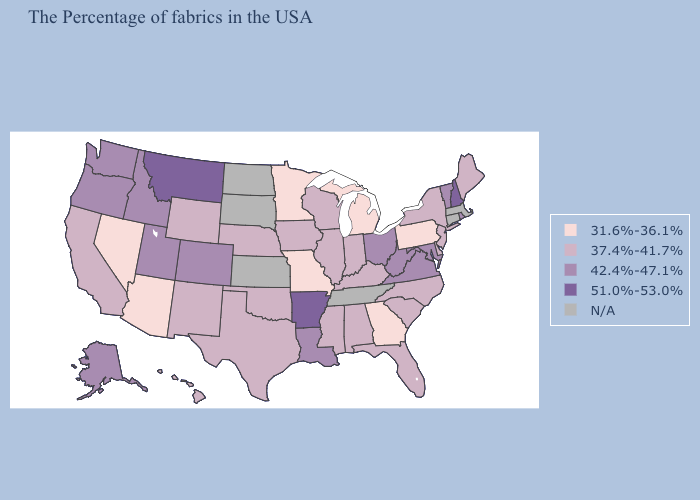What is the value of Ohio?
Short answer required. 42.4%-47.1%. Name the states that have a value in the range 31.6%-36.1%?
Answer briefly. Pennsylvania, Georgia, Michigan, Missouri, Minnesota, Arizona, Nevada. What is the value of Arizona?
Give a very brief answer. 31.6%-36.1%. Name the states that have a value in the range 51.0%-53.0%?
Short answer required. New Hampshire, Arkansas, Montana. What is the lowest value in the South?
Give a very brief answer. 31.6%-36.1%. Does California have the lowest value in the West?
Keep it brief. No. Among the states that border New Hampshire , does Vermont have the highest value?
Write a very short answer. Yes. What is the value of Nebraska?
Short answer required. 37.4%-41.7%. Name the states that have a value in the range 42.4%-47.1%?
Keep it brief. Rhode Island, Vermont, Maryland, Virginia, West Virginia, Ohio, Louisiana, Colorado, Utah, Idaho, Washington, Oregon, Alaska. What is the value of Maryland?
Quick response, please. 42.4%-47.1%. Name the states that have a value in the range 51.0%-53.0%?
Answer briefly. New Hampshire, Arkansas, Montana. 